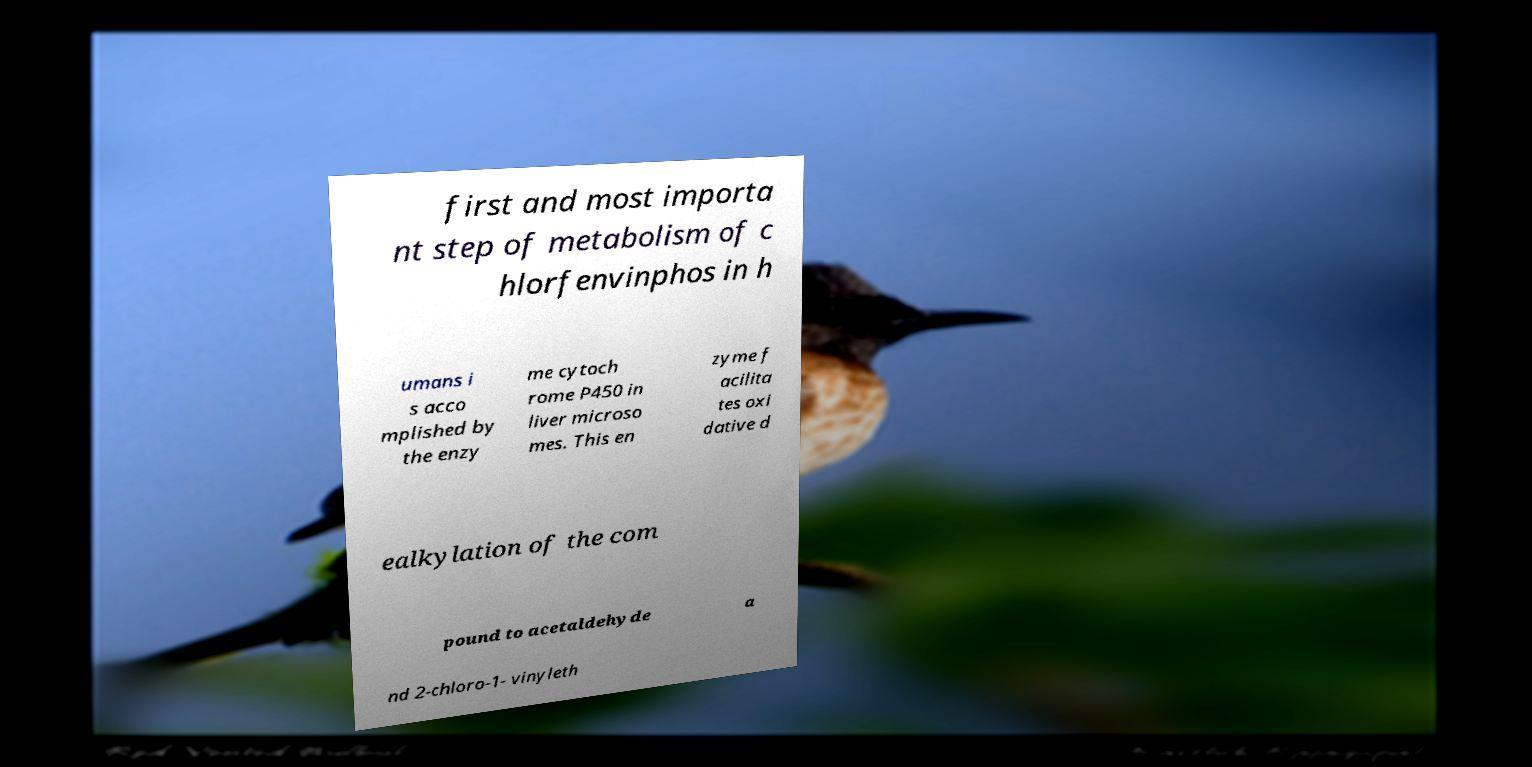Please read and relay the text visible in this image. What does it say? first and most importa nt step of metabolism of c hlorfenvinphos in h umans i s acco mplished by the enzy me cytoch rome P450 in liver microso mes. This en zyme f acilita tes oxi dative d ealkylation of the com pound to acetaldehyde a nd 2-chloro-1- vinyleth 